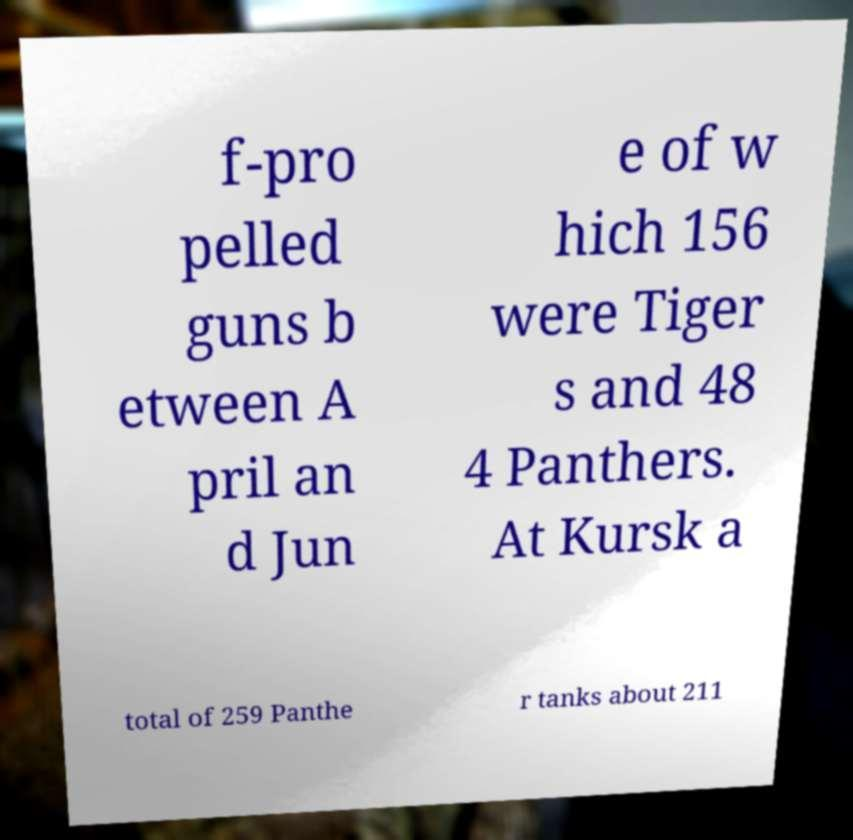Could you extract and type out the text from this image? f-pro pelled guns b etween A pril an d Jun e of w hich 156 were Tiger s and 48 4 Panthers. At Kursk a total of 259 Panthe r tanks about 211 